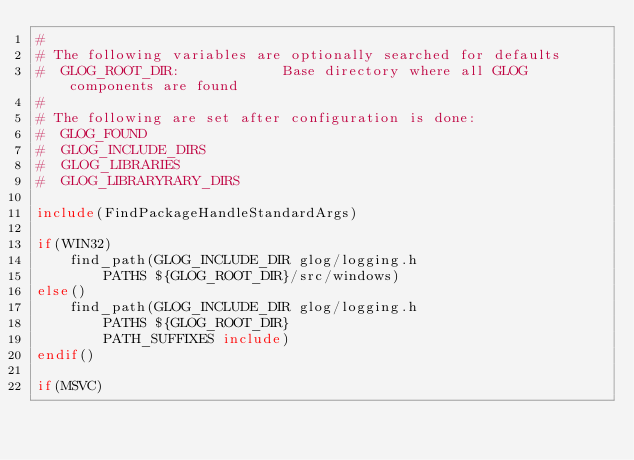Convert code to text. <code><loc_0><loc_0><loc_500><loc_500><_CMake_>#
# The following variables are optionally searched for defaults
#  GLOG_ROOT_DIR:            Base directory where all GLOG components are found
#
# The following are set after configuration is done:
#  GLOG_FOUND
#  GLOG_INCLUDE_DIRS
#  GLOG_LIBRARIES
#  GLOG_LIBRARYRARY_DIRS

include(FindPackageHandleStandardArgs)

if(WIN32)
    find_path(GLOG_INCLUDE_DIR glog/logging.h
        PATHS ${GLOG_ROOT_DIR}/src/windows)
else()
    find_path(GLOG_INCLUDE_DIR glog/logging.h
        PATHS ${GLOG_ROOT_DIR}
		PATH_SUFFIXES include)
endif()

if(MSVC)</code> 